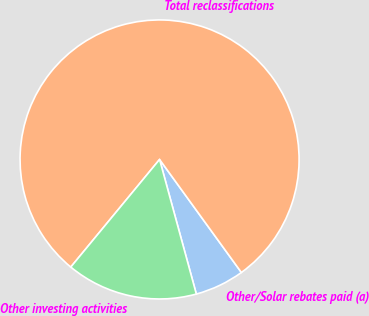Convert chart. <chart><loc_0><loc_0><loc_500><loc_500><pie_chart><fcel>Other/Solar rebates paid (a)<fcel>Total reclassifications<fcel>Other investing activities<nl><fcel>5.73%<fcel>79.04%<fcel>15.22%<nl></chart> 